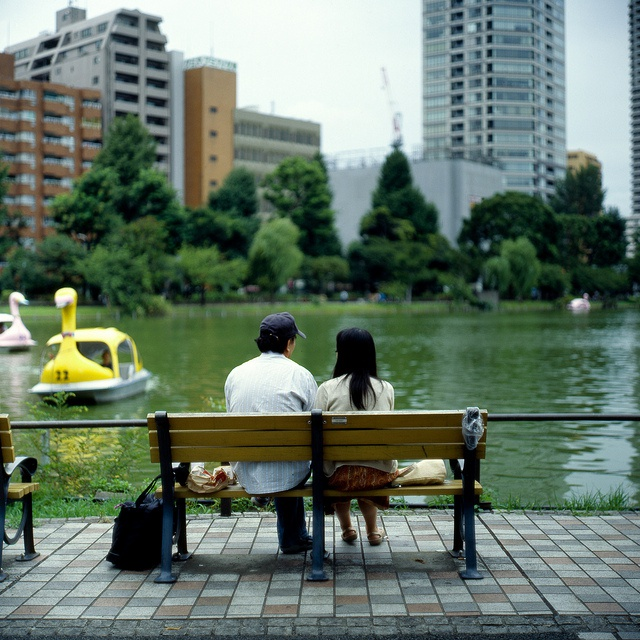Describe the objects in this image and their specific colors. I can see bench in lightblue, black, gray, and darkgray tones, people in lightblue, white, black, darkgray, and gray tones, people in lightblue, black, darkgray, gray, and lightgray tones, boat in lightblue, beige, khaki, and black tones, and handbag in lightblue, black, blue, navy, and gray tones in this image. 